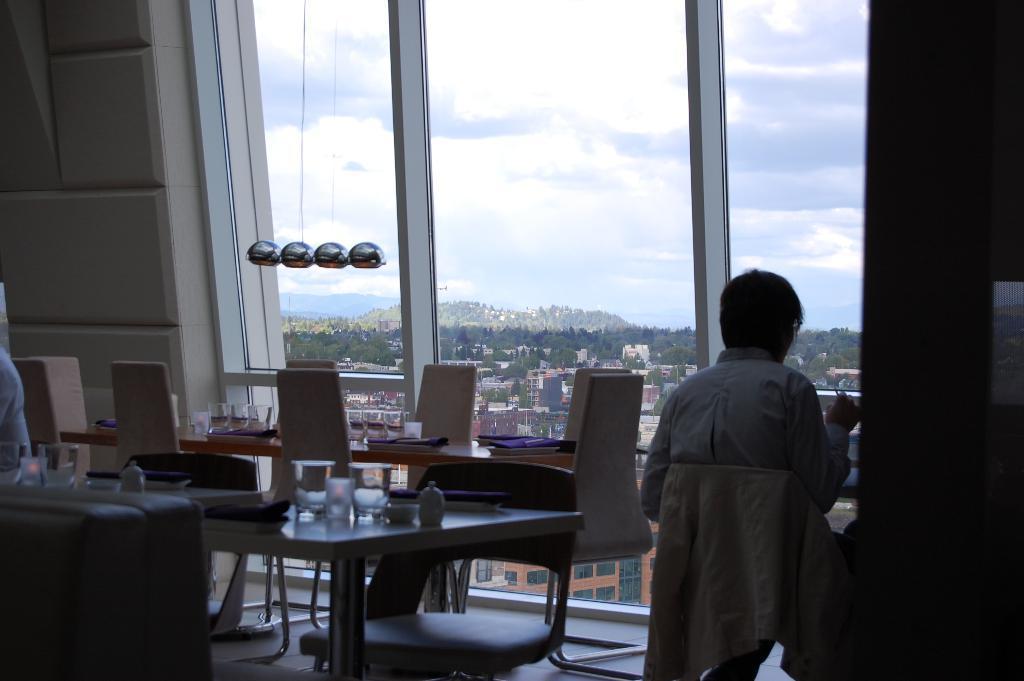Could you give a brief overview of what you see in this image? In this image I see a person sitting on the chair, I can also see there are lot of tables and chairs and there are few glasses on the tables. In the background I see the wall, windows, lot of buildings, trees and the sky. 